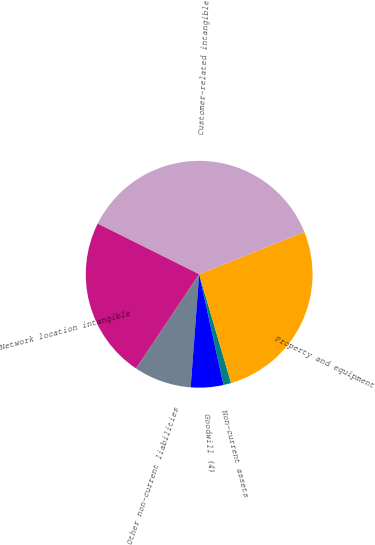Convert chart. <chart><loc_0><loc_0><loc_500><loc_500><pie_chart><fcel>Non-current assets<fcel>Property and equipment<fcel>Customer-related intangible<fcel>Network location intangible<fcel>Other non-current liabilities<fcel>Goodwill (4)<nl><fcel>1.1%<fcel>26.53%<fcel>36.56%<fcel>22.98%<fcel>8.19%<fcel>4.64%<nl></chart> 